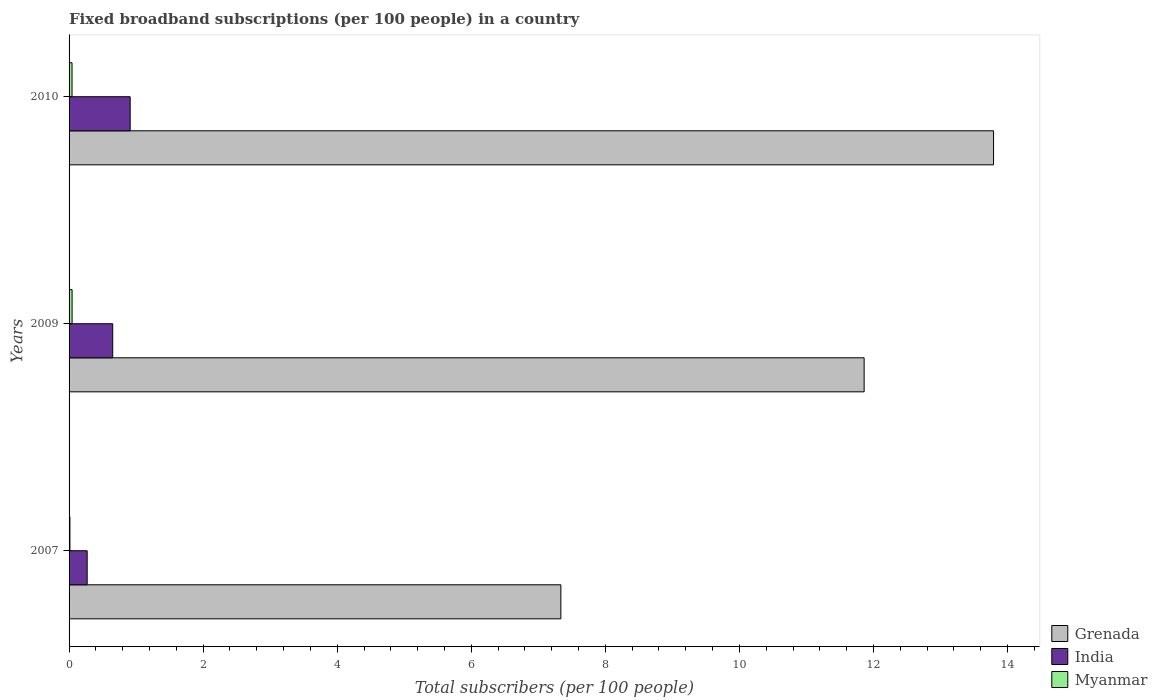How many different coloured bars are there?
Offer a terse response. 3. How many groups of bars are there?
Your answer should be compact. 3. Are the number of bars per tick equal to the number of legend labels?
Keep it short and to the point. Yes. Are the number of bars on each tick of the Y-axis equal?
Your response must be concise. Yes. What is the label of the 2nd group of bars from the top?
Provide a short and direct response. 2009. What is the number of broadband subscriptions in Grenada in 2007?
Ensure brevity in your answer.  7.34. Across all years, what is the maximum number of broadband subscriptions in Myanmar?
Ensure brevity in your answer.  0.05. Across all years, what is the minimum number of broadband subscriptions in Grenada?
Make the answer very short. 7.34. In which year was the number of broadband subscriptions in India maximum?
Provide a short and direct response. 2010. In which year was the number of broadband subscriptions in Grenada minimum?
Your answer should be very brief. 2007. What is the total number of broadband subscriptions in Grenada in the graph?
Your answer should be very brief. 32.99. What is the difference between the number of broadband subscriptions in India in 2007 and that in 2010?
Provide a succinct answer. -0.64. What is the difference between the number of broadband subscriptions in India in 2010 and the number of broadband subscriptions in Myanmar in 2007?
Provide a short and direct response. 0.9. What is the average number of broadband subscriptions in India per year?
Ensure brevity in your answer.  0.61. In the year 2009, what is the difference between the number of broadband subscriptions in Myanmar and number of broadband subscriptions in Grenada?
Keep it short and to the point. -11.82. What is the ratio of the number of broadband subscriptions in India in 2009 to that in 2010?
Your response must be concise. 0.71. Is the number of broadband subscriptions in Grenada in 2009 less than that in 2010?
Your response must be concise. Yes. What is the difference between the highest and the second highest number of broadband subscriptions in Myanmar?
Offer a terse response. 0. What is the difference between the highest and the lowest number of broadband subscriptions in Myanmar?
Offer a terse response. 0.03. Is the sum of the number of broadband subscriptions in Grenada in 2007 and 2010 greater than the maximum number of broadband subscriptions in India across all years?
Give a very brief answer. Yes. What does the 3rd bar from the top in 2010 represents?
Your answer should be compact. Grenada. What does the 1st bar from the bottom in 2007 represents?
Make the answer very short. Grenada. How many bars are there?
Offer a terse response. 9. Are all the bars in the graph horizontal?
Give a very brief answer. Yes. What is the difference between two consecutive major ticks on the X-axis?
Your answer should be very brief. 2. Does the graph contain any zero values?
Ensure brevity in your answer.  No. How many legend labels are there?
Offer a very short reply. 3. How are the legend labels stacked?
Give a very brief answer. Vertical. What is the title of the graph?
Give a very brief answer. Fixed broadband subscriptions (per 100 people) in a country. Does "Burkina Faso" appear as one of the legend labels in the graph?
Provide a short and direct response. No. What is the label or title of the X-axis?
Ensure brevity in your answer.  Total subscribers (per 100 people). What is the label or title of the Y-axis?
Ensure brevity in your answer.  Years. What is the Total subscribers (per 100 people) of Grenada in 2007?
Give a very brief answer. 7.34. What is the Total subscribers (per 100 people) in India in 2007?
Provide a succinct answer. 0.27. What is the Total subscribers (per 100 people) in Myanmar in 2007?
Keep it short and to the point. 0.01. What is the Total subscribers (per 100 people) of Grenada in 2009?
Your answer should be very brief. 11.86. What is the Total subscribers (per 100 people) in India in 2009?
Make the answer very short. 0.65. What is the Total subscribers (per 100 people) in Myanmar in 2009?
Ensure brevity in your answer.  0.05. What is the Total subscribers (per 100 people) of Grenada in 2010?
Your answer should be compact. 13.79. What is the Total subscribers (per 100 people) of India in 2010?
Make the answer very short. 0.91. What is the Total subscribers (per 100 people) of Myanmar in 2010?
Your answer should be very brief. 0.04. Across all years, what is the maximum Total subscribers (per 100 people) of Grenada?
Give a very brief answer. 13.79. Across all years, what is the maximum Total subscribers (per 100 people) of India?
Provide a short and direct response. 0.91. Across all years, what is the maximum Total subscribers (per 100 people) of Myanmar?
Provide a short and direct response. 0.05. Across all years, what is the minimum Total subscribers (per 100 people) in Grenada?
Provide a succinct answer. 7.34. Across all years, what is the minimum Total subscribers (per 100 people) in India?
Ensure brevity in your answer.  0.27. Across all years, what is the minimum Total subscribers (per 100 people) of Myanmar?
Offer a very short reply. 0.01. What is the total Total subscribers (per 100 people) in Grenada in the graph?
Provide a succinct answer. 32.99. What is the total Total subscribers (per 100 people) in India in the graph?
Offer a very short reply. 1.83. What is the total Total subscribers (per 100 people) in Myanmar in the graph?
Ensure brevity in your answer.  0.1. What is the difference between the Total subscribers (per 100 people) of Grenada in 2007 and that in 2009?
Your response must be concise. -4.52. What is the difference between the Total subscribers (per 100 people) in India in 2007 and that in 2009?
Offer a terse response. -0.38. What is the difference between the Total subscribers (per 100 people) of Myanmar in 2007 and that in 2009?
Your response must be concise. -0.03. What is the difference between the Total subscribers (per 100 people) in Grenada in 2007 and that in 2010?
Offer a very short reply. -6.46. What is the difference between the Total subscribers (per 100 people) of India in 2007 and that in 2010?
Your answer should be very brief. -0.64. What is the difference between the Total subscribers (per 100 people) in Myanmar in 2007 and that in 2010?
Provide a short and direct response. -0.03. What is the difference between the Total subscribers (per 100 people) of Grenada in 2009 and that in 2010?
Provide a short and direct response. -1.93. What is the difference between the Total subscribers (per 100 people) in India in 2009 and that in 2010?
Your answer should be very brief. -0.26. What is the difference between the Total subscribers (per 100 people) of Myanmar in 2009 and that in 2010?
Your answer should be compact. 0. What is the difference between the Total subscribers (per 100 people) of Grenada in 2007 and the Total subscribers (per 100 people) of India in 2009?
Make the answer very short. 6.69. What is the difference between the Total subscribers (per 100 people) of Grenada in 2007 and the Total subscribers (per 100 people) of Myanmar in 2009?
Offer a terse response. 7.29. What is the difference between the Total subscribers (per 100 people) in India in 2007 and the Total subscribers (per 100 people) in Myanmar in 2009?
Make the answer very short. 0.22. What is the difference between the Total subscribers (per 100 people) of Grenada in 2007 and the Total subscribers (per 100 people) of India in 2010?
Ensure brevity in your answer.  6.43. What is the difference between the Total subscribers (per 100 people) in Grenada in 2007 and the Total subscribers (per 100 people) in Myanmar in 2010?
Offer a very short reply. 7.29. What is the difference between the Total subscribers (per 100 people) in India in 2007 and the Total subscribers (per 100 people) in Myanmar in 2010?
Offer a very short reply. 0.23. What is the difference between the Total subscribers (per 100 people) of Grenada in 2009 and the Total subscribers (per 100 people) of India in 2010?
Provide a succinct answer. 10.95. What is the difference between the Total subscribers (per 100 people) in Grenada in 2009 and the Total subscribers (per 100 people) in Myanmar in 2010?
Make the answer very short. 11.82. What is the difference between the Total subscribers (per 100 people) in India in 2009 and the Total subscribers (per 100 people) in Myanmar in 2010?
Your answer should be compact. 0.61. What is the average Total subscribers (per 100 people) in Grenada per year?
Ensure brevity in your answer.  11. What is the average Total subscribers (per 100 people) in India per year?
Offer a very short reply. 0.61. What is the average Total subscribers (per 100 people) of Myanmar per year?
Provide a succinct answer. 0.03. In the year 2007, what is the difference between the Total subscribers (per 100 people) of Grenada and Total subscribers (per 100 people) of India?
Your answer should be very brief. 7.07. In the year 2007, what is the difference between the Total subscribers (per 100 people) of Grenada and Total subscribers (per 100 people) of Myanmar?
Your answer should be compact. 7.32. In the year 2007, what is the difference between the Total subscribers (per 100 people) of India and Total subscribers (per 100 people) of Myanmar?
Offer a very short reply. 0.26. In the year 2009, what is the difference between the Total subscribers (per 100 people) of Grenada and Total subscribers (per 100 people) of India?
Your answer should be compact. 11.21. In the year 2009, what is the difference between the Total subscribers (per 100 people) of Grenada and Total subscribers (per 100 people) of Myanmar?
Offer a terse response. 11.82. In the year 2009, what is the difference between the Total subscribers (per 100 people) in India and Total subscribers (per 100 people) in Myanmar?
Your response must be concise. 0.61. In the year 2010, what is the difference between the Total subscribers (per 100 people) in Grenada and Total subscribers (per 100 people) in India?
Provide a short and direct response. 12.88. In the year 2010, what is the difference between the Total subscribers (per 100 people) in Grenada and Total subscribers (per 100 people) in Myanmar?
Your response must be concise. 13.75. In the year 2010, what is the difference between the Total subscribers (per 100 people) of India and Total subscribers (per 100 people) of Myanmar?
Offer a terse response. 0.87. What is the ratio of the Total subscribers (per 100 people) in Grenada in 2007 to that in 2009?
Provide a short and direct response. 0.62. What is the ratio of the Total subscribers (per 100 people) in India in 2007 to that in 2009?
Provide a short and direct response. 0.41. What is the ratio of the Total subscribers (per 100 people) in Myanmar in 2007 to that in 2009?
Offer a terse response. 0.28. What is the ratio of the Total subscribers (per 100 people) in Grenada in 2007 to that in 2010?
Give a very brief answer. 0.53. What is the ratio of the Total subscribers (per 100 people) of India in 2007 to that in 2010?
Make the answer very short. 0.3. What is the ratio of the Total subscribers (per 100 people) of Myanmar in 2007 to that in 2010?
Keep it short and to the point. 0.29. What is the ratio of the Total subscribers (per 100 people) of Grenada in 2009 to that in 2010?
Your response must be concise. 0.86. What is the ratio of the Total subscribers (per 100 people) in India in 2009 to that in 2010?
Provide a short and direct response. 0.71. What is the ratio of the Total subscribers (per 100 people) in Myanmar in 2009 to that in 2010?
Keep it short and to the point. 1.02. What is the difference between the highest and the second highest Total subscribers (per 100 people) in Grenada?
Offer a terse response. 1.93. What is the difference between the highest and the second highest Total subscribers (per 100 people) in India?
Your answer should be compact. 0.26. What is the difference between the highest and the second highest Total subscribers (per 100 people) in Myanmar?
Your response must be concise. 0. What is the difference between the highest and the lowest Total subscribers (per 100 people) of Grenada?
Keep it short and to the point. 6.46. What is the difference between the highest and the lowest Total subscribers (per 100 people) of India?
Make the answer very short. 0.64. What is the difference between the highest and the lowest Total subscribers (per 100 people) of Myanmar?
Your answer should be very brief. 0.03. 